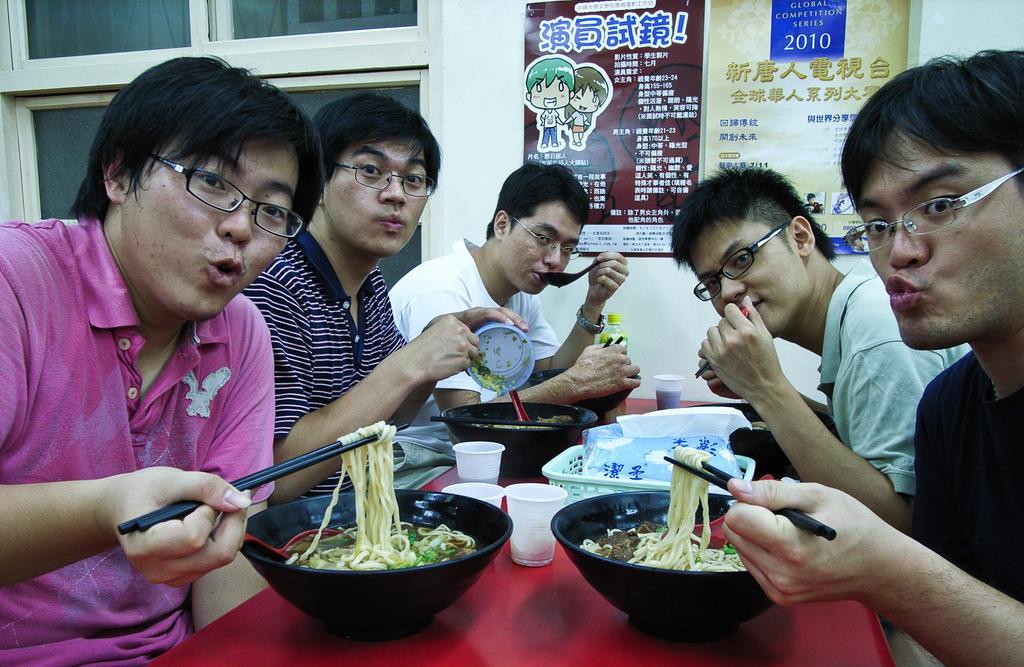Please provide a concise description of this image. In this image we can see group of people are are eating some food items. On the top of the image we can see two posters. 